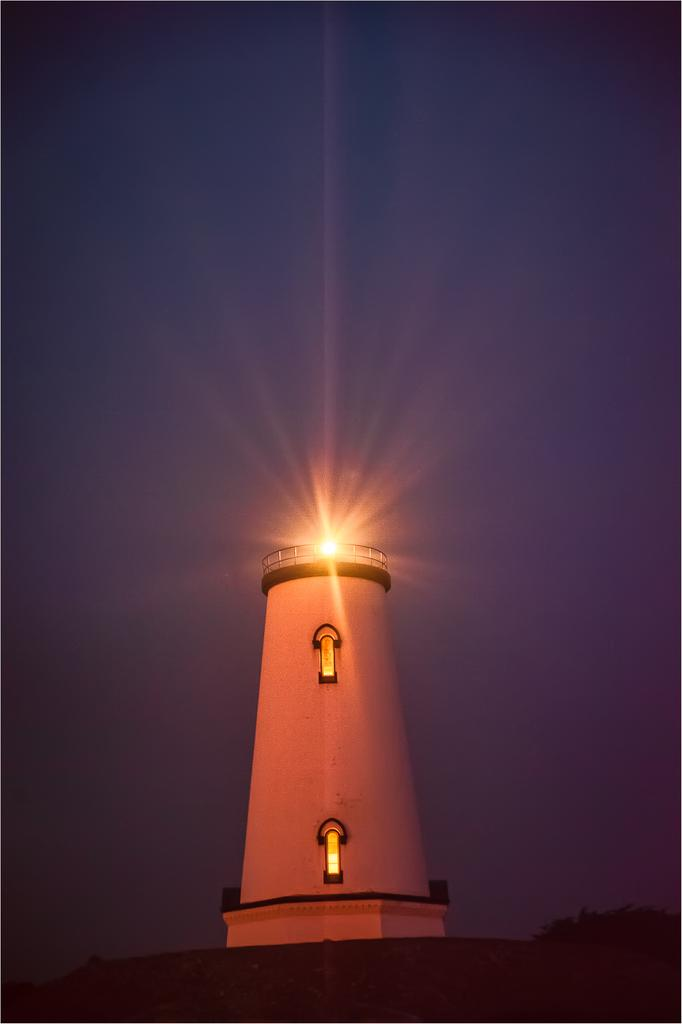What is the main structure in the image? There is a lighthouse in the image. Where is the lighthouse located in relation to the image? The lighthouse is at the bottom of the image. How many windows are visible on the lighthouse? The lighthouse has two windows. What can be seen at the top of the image? The sky is visible at the top of the image. What type of gold shoes can be seen on the lighthouse in the image? There are no shoes, gold or otherwise, present in the image. The image features a lighthouse with two windows and a visible sky. 